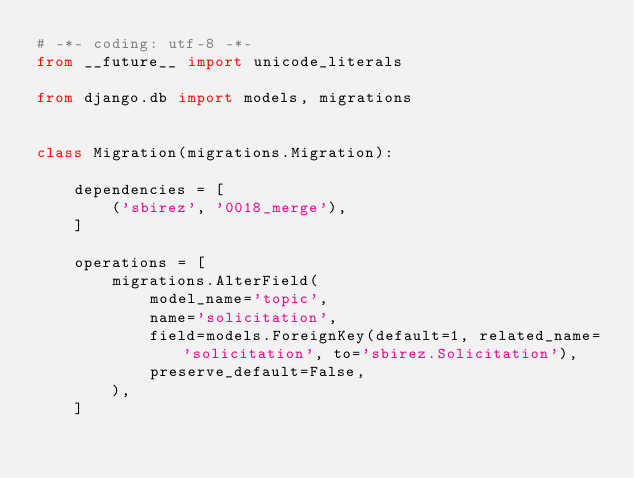<code> <loc_0><loc_0><loc_500><loc_500><_Python_># -*- coding: utf-8 -*-
from __future__ import unicode_literals

from django.db import models, migrations


class Migration(migrations.Migration):

    dependencies = [
        ('sbirez', '0018_merge'),
    ]

    operations = [
        migrations.AlterField(
            model_name='topic',
            name='solicitation',
            field=models.ForeignKey(default=1, related_name='solicitation', to='sbirez.Solicitation'),
            preserve_default=False,
        ),
    ]
</code> 